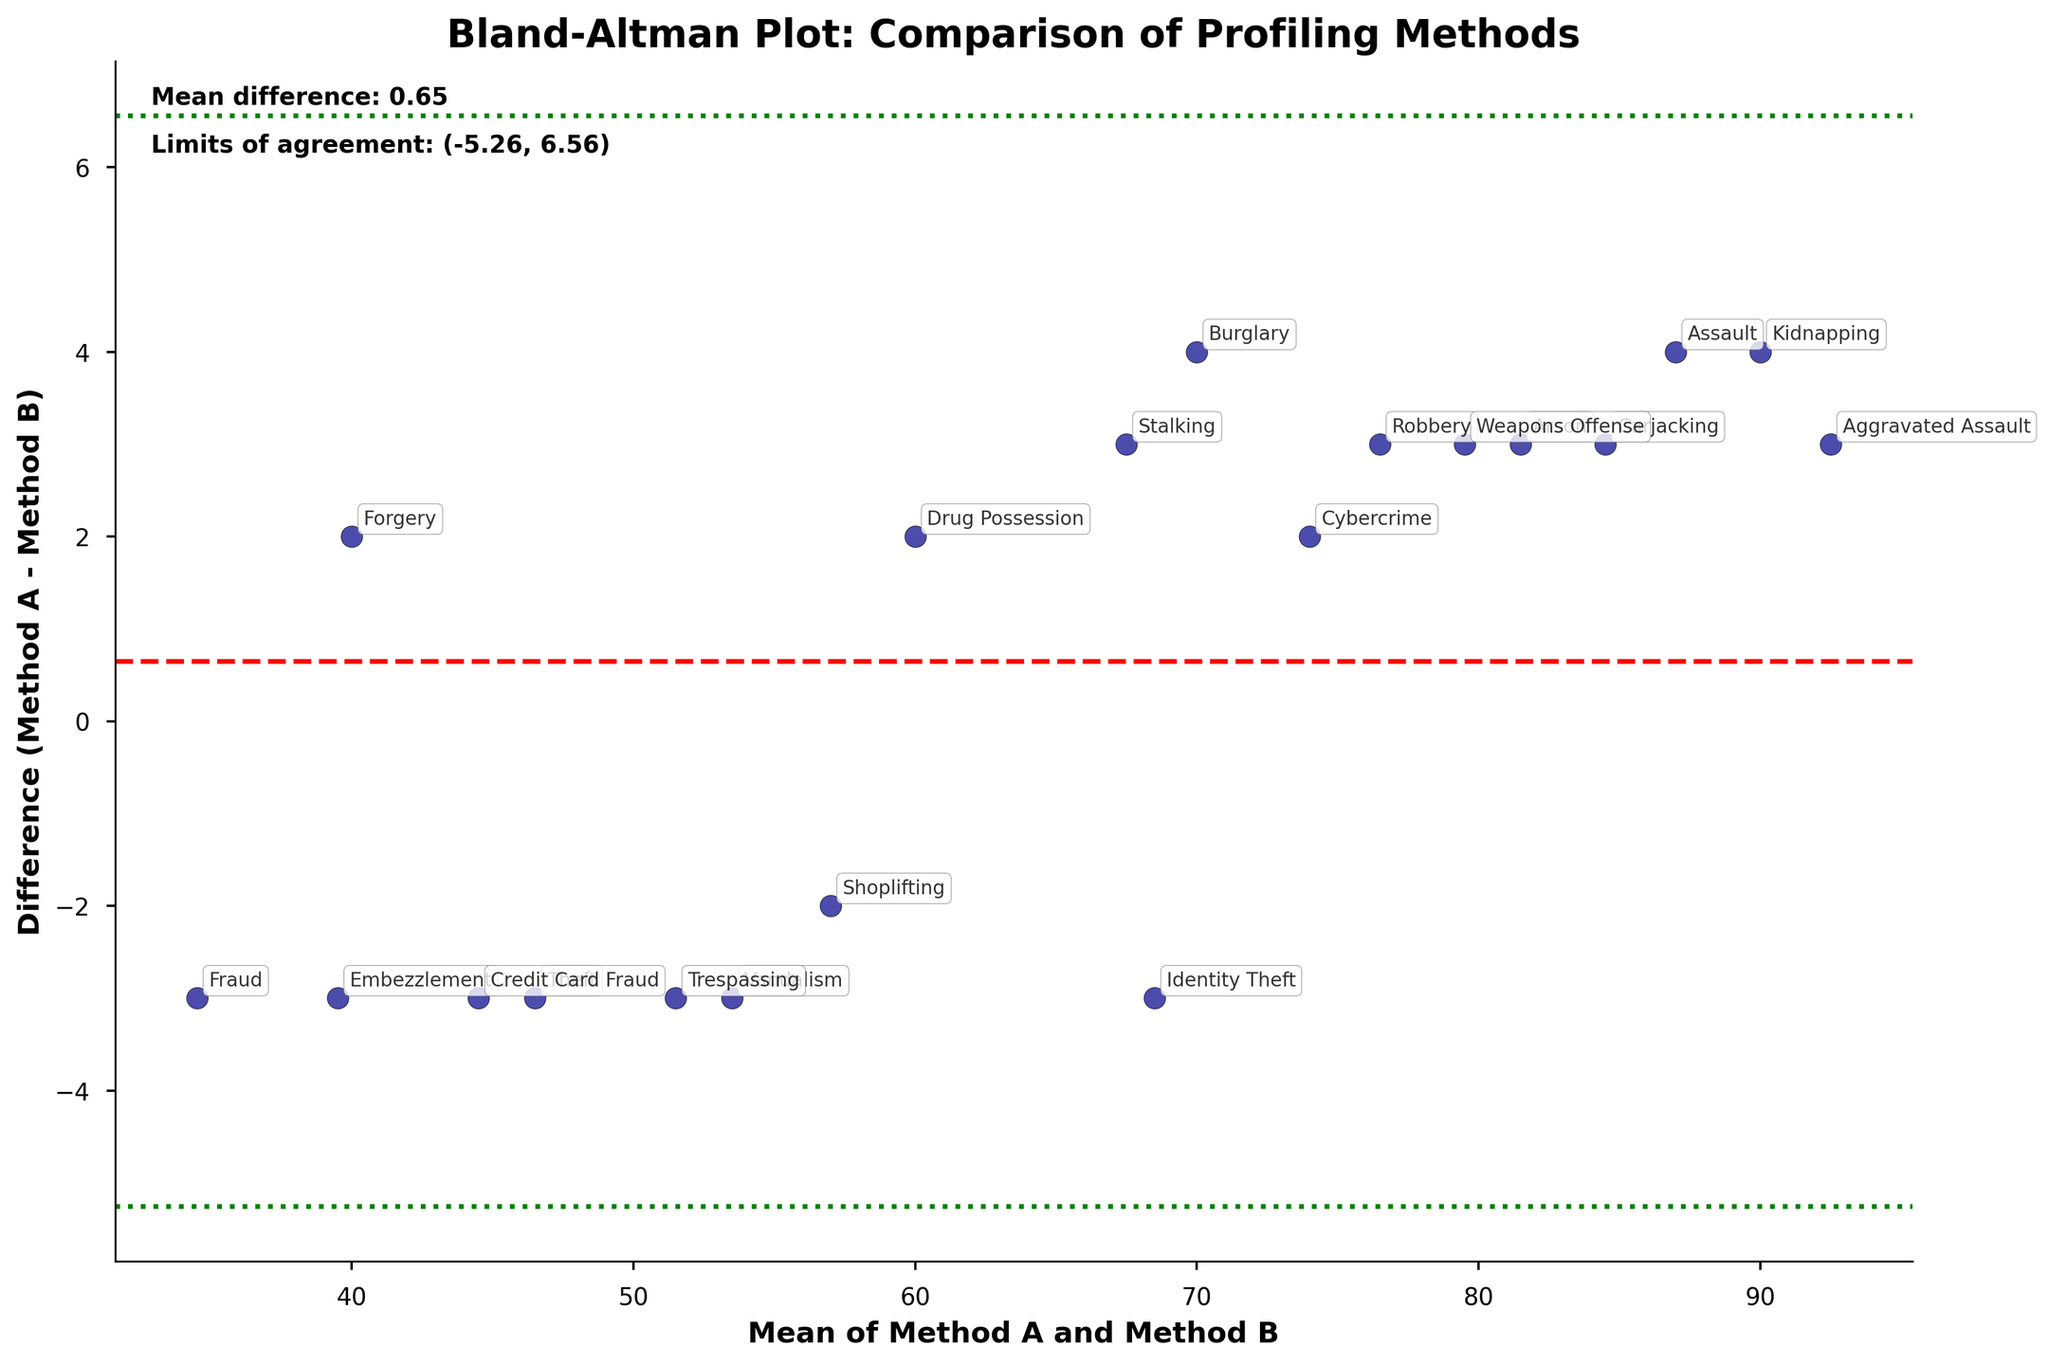How many offense types are plotted in the Bland-Altman plot? To determine the number of offense types, count the discrete data points plotted on the figure. Each data point represents an offense type.
Answer: 20 What is the title of the plot? Look at the top of the plot where the title is usually displayed.
Answer: Bland-Altman Plot: Comparison of Profiling Methods What does the red dashed line represent in the Bland-Altman plot? Identify the red dashed line in the plot and understand its context in a Bland-Altman analysis, which typically denotes the mean difference between two methods.
Answer: Mean difference What are the green dotted lines on the plot? In Bland-Altman plots, green dotted lines typically represent the limits of agreement, which are calculated using the mean difference and the standard deviation.
Answer: Limits of agreement Which offense type has the greatest positive difference between Method A and Method B? Find the highest point on the y-axis where the difference (Method A - Method B) is plotted. The offense type corresponding to this point is the one sought.
Answer: Embezzlement Which offense type has the closest agreement between Method A and Method B? Identify the data point closest to the red dashed line (mean difference of zero) on the plot. This indicates the least difference between the two methods.
Answer: Weapons Offense What is the mean difference between Method A and Method B? In Bland-Altman plots, the mean difference is typically indicated and, in this case, displayed on the plot.
Answer: 2.10 What are the limits of agreement for the comparison of Method A and Method B? The limits of agreement are often shown as green dotted lines and noted on the plot.
Answer: (-1.89, 6.09) Which offense type appears to be consistently underestimated by Method A compared to Method B? Look for offense types represented by points below the red dashed line (negative differences). Identify the offense type closest to the lower limit of agreement if consistently underestimated.
Answer: Identity Theft Are there more offense types with positive or negative differences between Method A and Method B? Count the number of points above (positive differences) and below (negative differences) the red dashed line.
Answer: Negative 